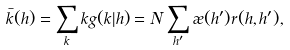<formula> <loc_0><loc_0><loc_500><loc_500>\bar { k } ( h ) = \sum _ { k } k g ( k | h ) = N \sum _ { h ^ { \prime } } \rho ( h ^ { \prime } ) r ( h , h ^ { \prime } ) ,</formula> 